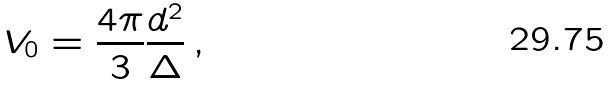<formula> <loc_0><loc_0><loc_500><loc_500>V _ { 0 } = \frac { 4 \pi } { 3 } \frac { d ^ { 2 } } { \Delta } \, ,</formula> 